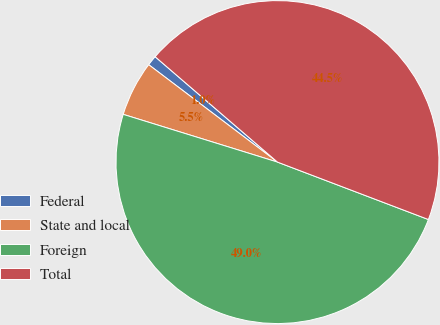Convert chart to OTSL. <chart><loc_0><loc_0><loc_500><loc_500><pie_chart><fcel>Federal<fcel>State and local<fcel>Foreign<fcel>Total<nl><fcel>1.01%<fcel>5.53%<fcel>48.99%<fcel>44.47%<nl></chart> 